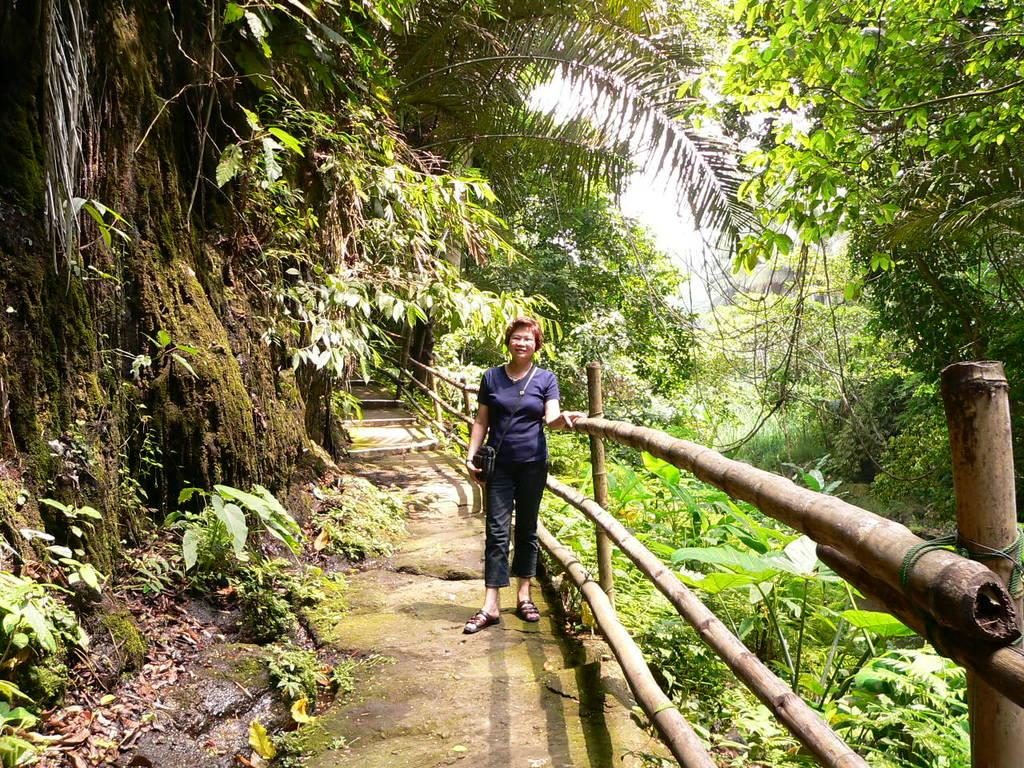Who or what is present in the image? There is a person in the image. What can be seen in the background of the image? There is a fence, grass, plants, trees, and the sky visible in the image. What is the ground like in the image? The ground is visible in the image. What type of cork can be seen in the image? There is no cork present in the image. How does the person twist in the image? The person is not twisting in the image; they are standing or walking. 